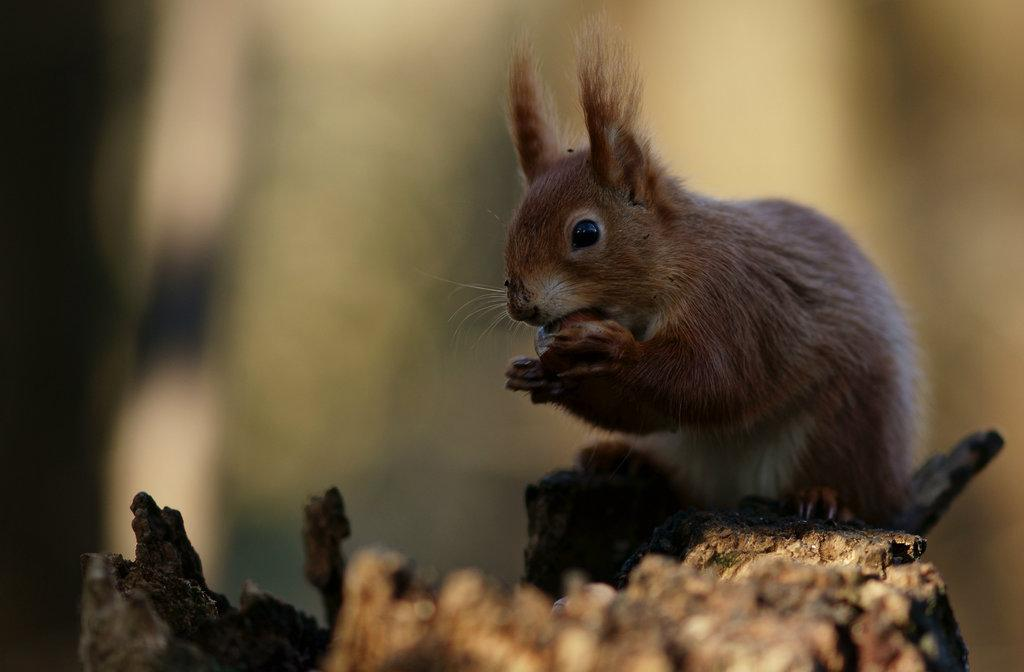Where was the image most likely taken? The image was likely taken outside. What can be seen in the foreground of the image? There is an animal sitting on a rock in the image. What is the animal doing in the image? The animal appears to be eating something. Can you describe the background of the image? The background of the image is blurry. What news story is the animal discussing with the hole in the image? There is no hole or news story present in the image. The animal is simply sitting on a rock and eating something. 